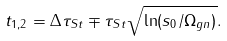<formula> <loc_0><loc_0><loc_500><loc_500>t _ { 1 , 2 } = \Delta \tau _ { S t } \mp \tau _ { S t } \sqrt { \ln ( { s _ { 0 } } / { \Omega _ { g n } ) } } .</formula> 